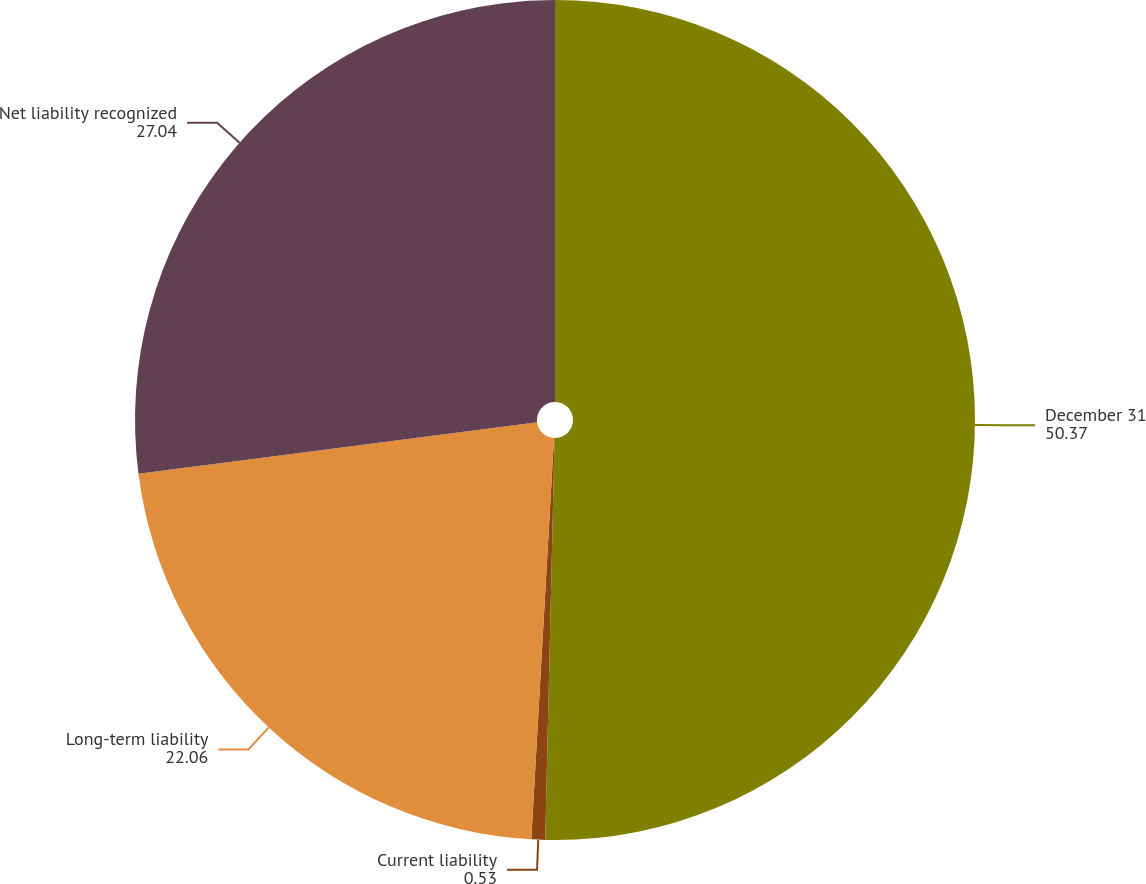Convert chart. <chart><loc_0><loc_0><loc_500><loc_500><pie_chart><fcel>December 31<fcel>Current liability<fcel>Long-term liability<fcel>Net liability recognized<nl><fcel>50.37%<fcel>0.53%<fcel>22.06%<fcel>27.04%<nl></chart> 